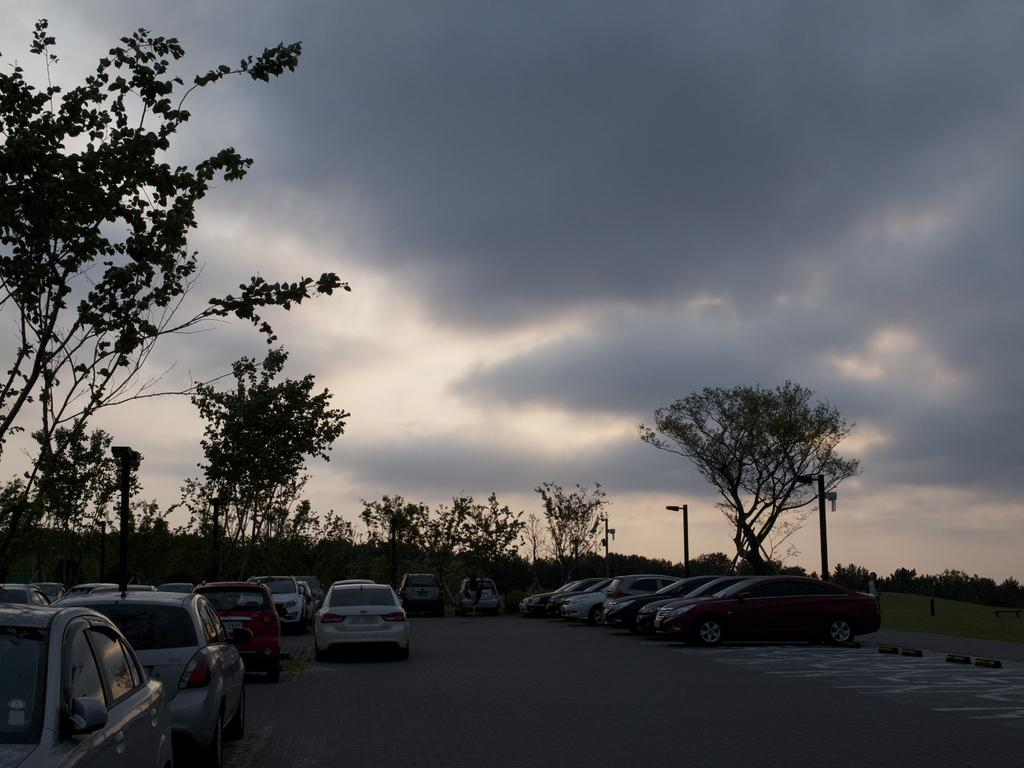What can be seen on the road in the image? There are cars on the road in the image. What type of natural elements can be seen in the background? Trees are visible in the background of the image. What kind of artificial lighting is present in the background? There are lights on poles in the background of the image. What is visible in the sky in the image? The sky is visible with clouds in the image. What type of skirt is the expert wearing in the image? There is no expert or skirt present in the image. Can you tell me how many donkeys are visible in the image? There are no donkeys present in the image. 